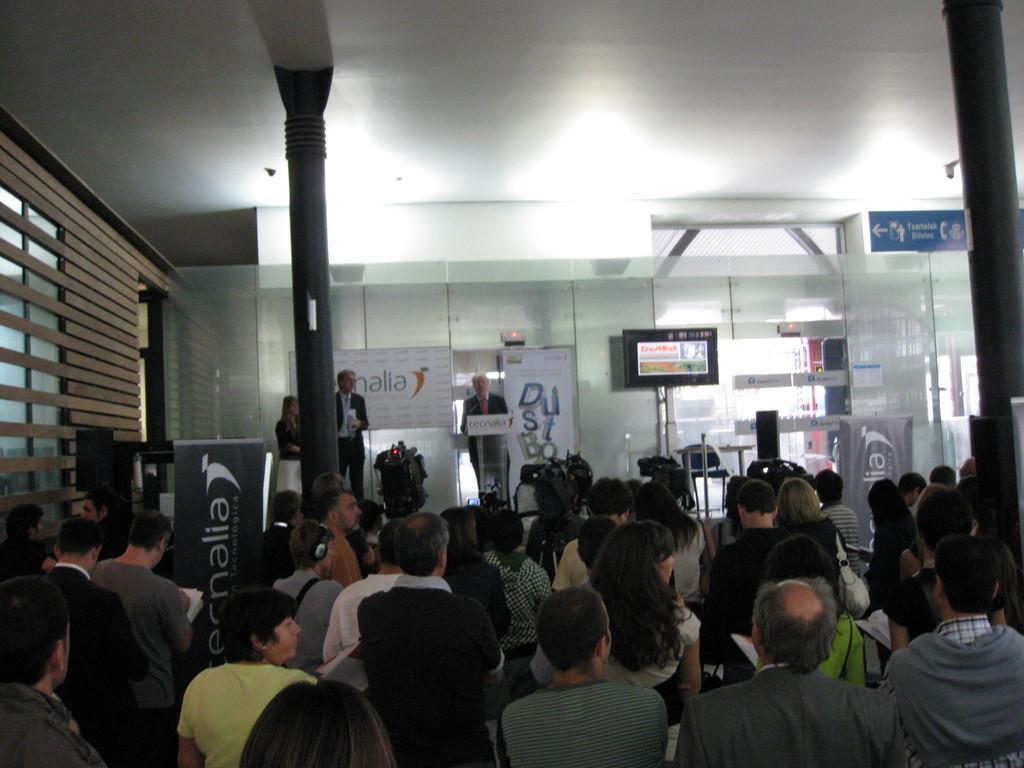Describe this image in one or two sentences. There are groups of people standing. These are the video recorders. I can see a man standing near the podium. This looks like a banner. I can see the posts and a screen attached to the glass. Here is a chair. 